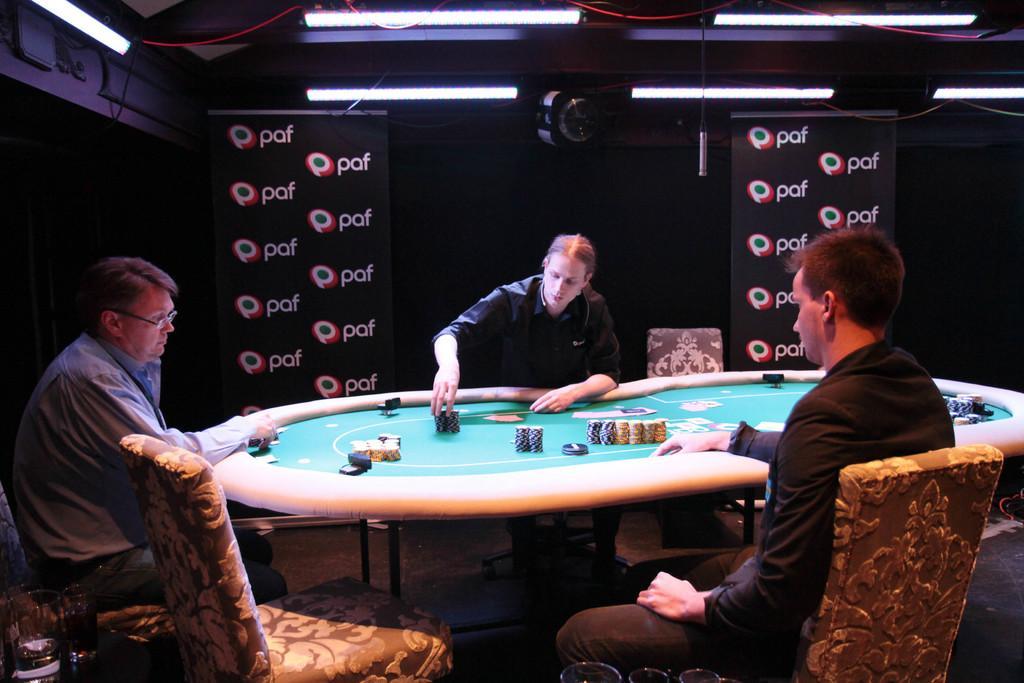How would you summarize this image in a sentence or two? As we can see in the image there is a camera, three people sitting on chairs. 